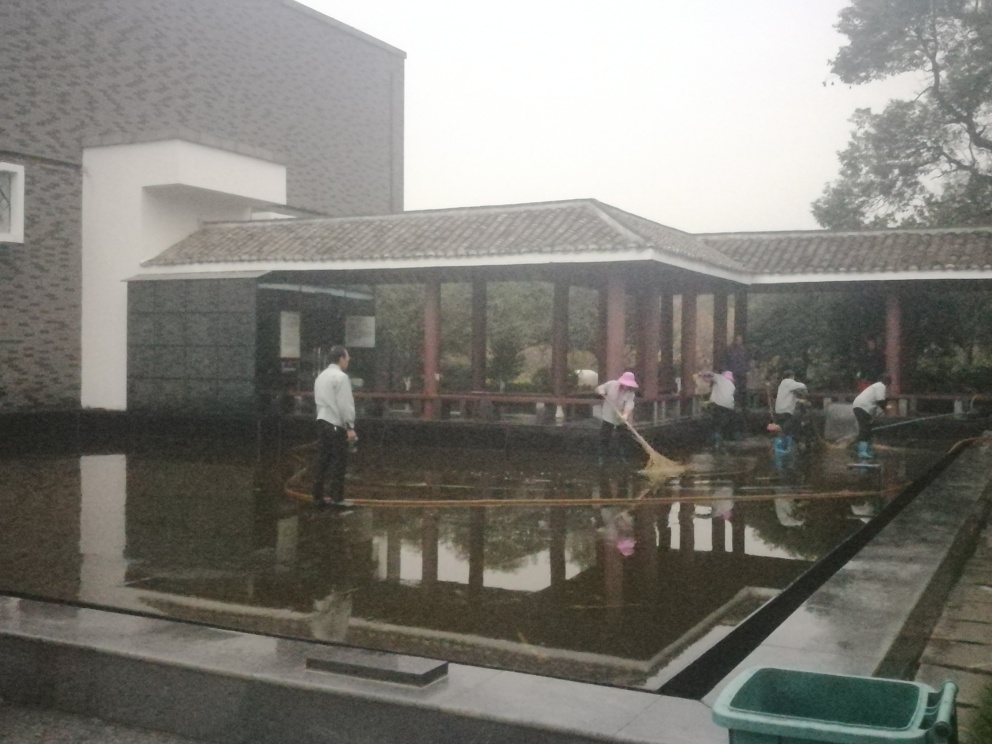What are the people in the image doing? The individuals in the image are engaged in cleaning a body of water, likely a pond or a shallow pool. They are using long-handled tools to remove debris or algae, indicating a maintenance activity to keep the water clean. Does the weather in the image affect their activity? The overcast sky suggests it may have recently rained, which could make the cleaning task more challenging due to potential waterlogging and slippery conditions. However, it also provides a cooler environment which can be more comfortable for physical labor. 